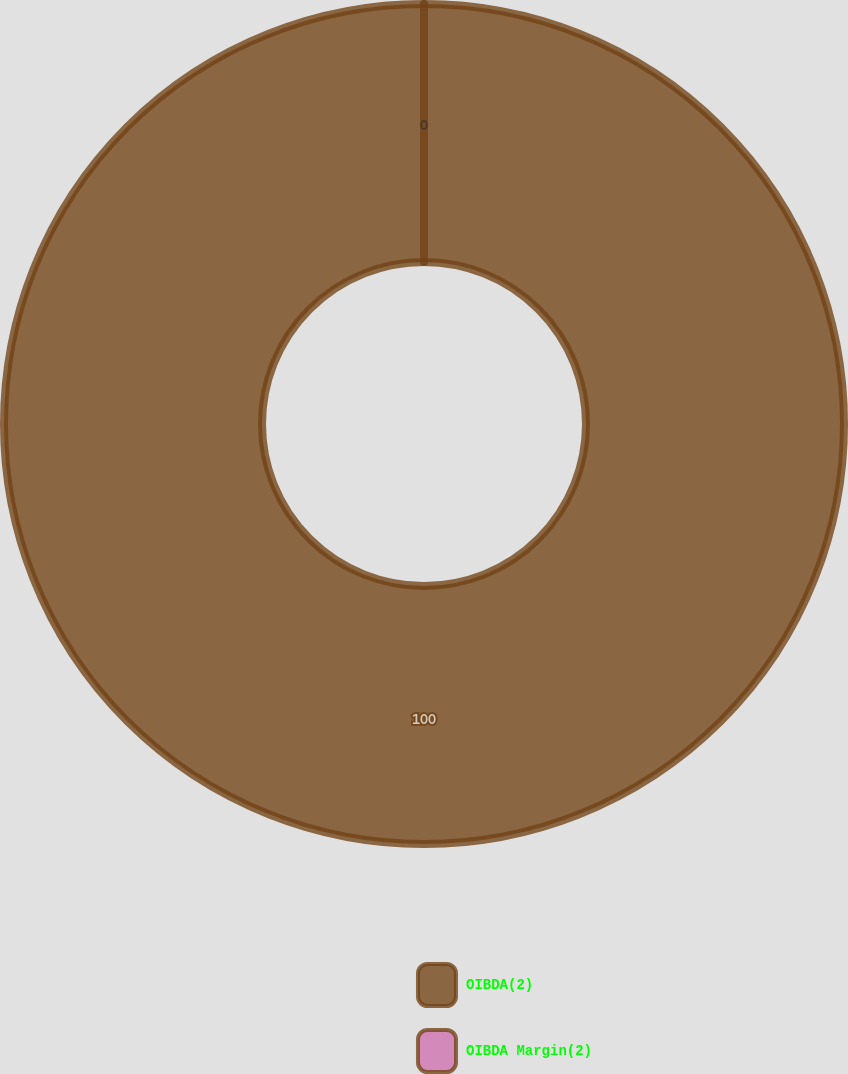Convert chart. <chart><loc_0><loc_0><loc_500><loc_500><pie_chart><fcel>OIBDA(2)<fcel>OIBDA Margin(2)<nl><fcel>100.0%<fcel>0.0%<nl></chart> 